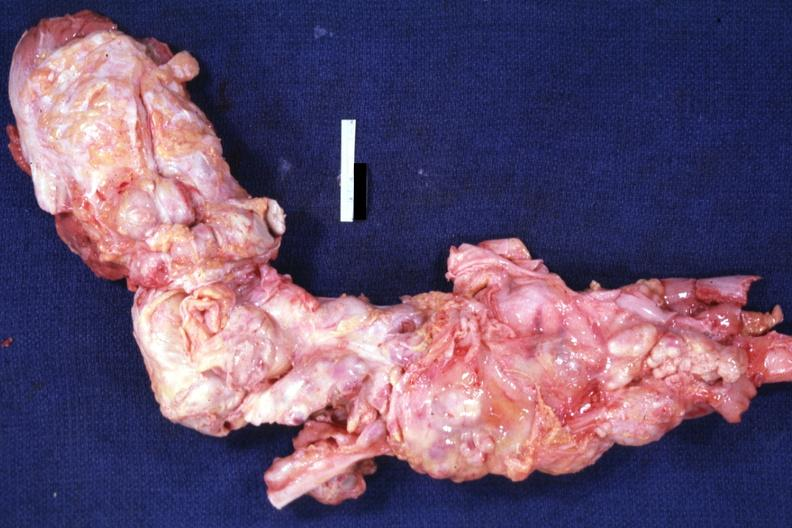s hodgkins disease present?
Answer the question using a single word or phrase. Yes 